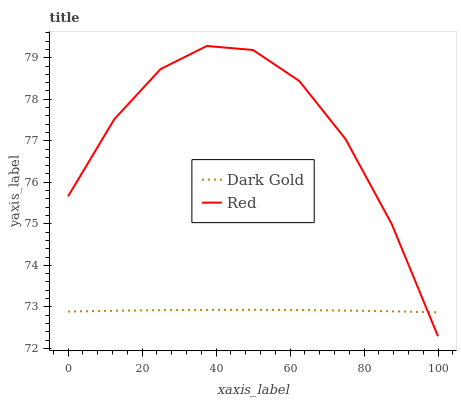Does Dark Gold have the minimum area under the curve?
Answer yes or no. Yes. Does Red have the maximum area under the curve?
Answer yes or no. Yes. Does Dark Gold have the maximum area under the curve?
Answer yes or no. No. Is Dark Gold the smoothest?
Answer yes or no. Yes. Is Red the roughest?
Answer yes or no. Yes. Is Dark Gold the roughest?
Answer yes or no. No. Does Red have the lowest value?
Answer yes or no. Yes. Does Dark Gold have the lowest value?
Answer yes or no. No. Does Red have the highest value?
Answer yes or no. Yes. Does Dark Gold have the highest value?
Answer yes or no. No. Does Dark Gold intersect Red?
Answer yes or no. Yes. Is Dark Gold less than Red?
Answer yes or no. No. Is Dark Gold greater than Red?
Answer yes or no. No. 